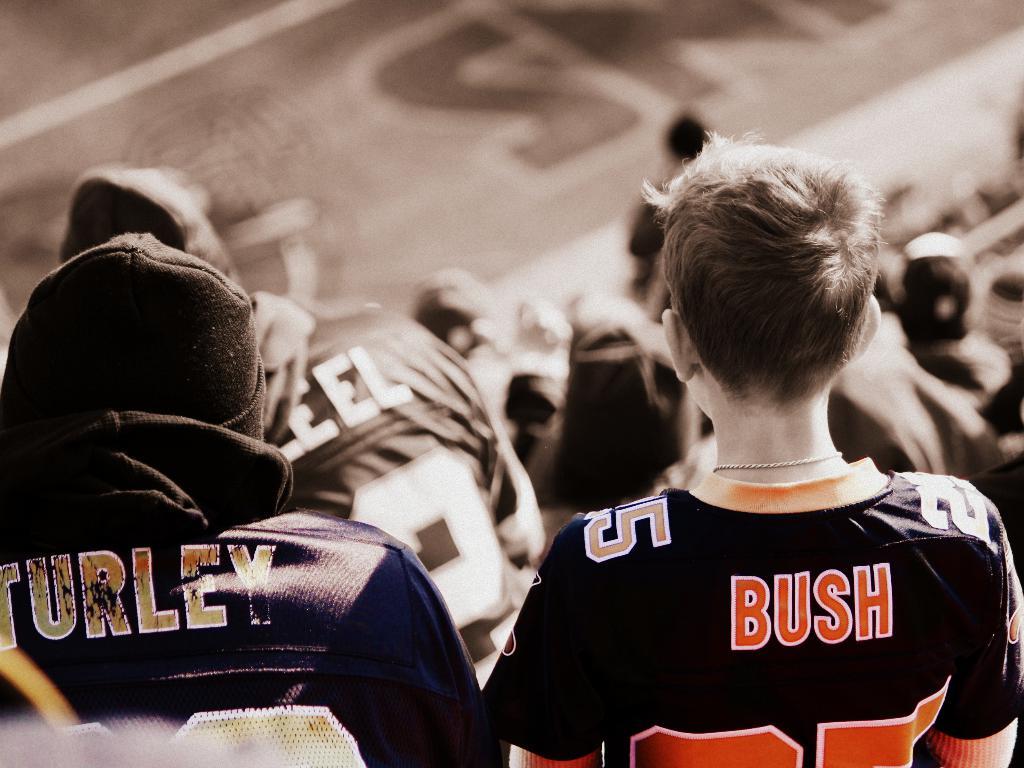What football player's name is shown on the jersey on the right?
Offer a terse response. Bush. What team does the person on the left support by wearing their jersey?
Your response must be concise. Unanswerable. 